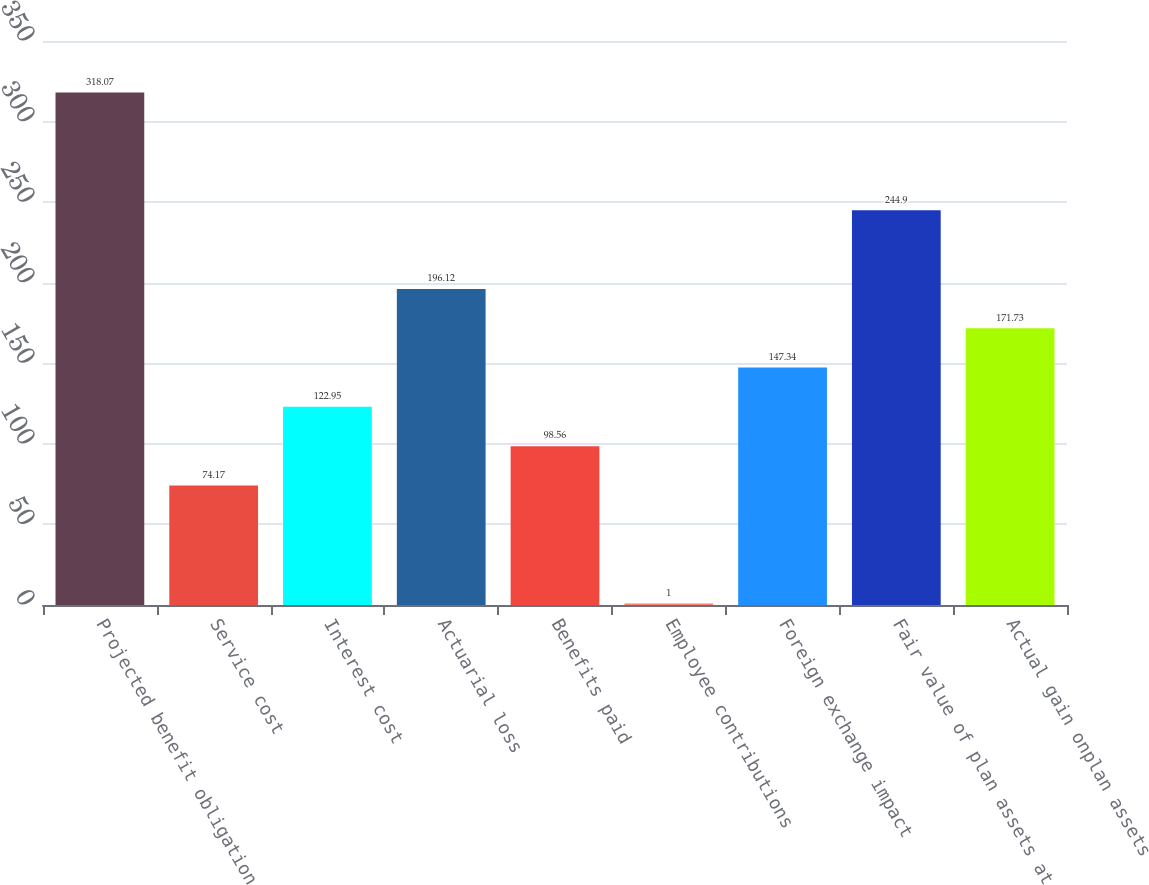Convert chart. <chart><loc_0><loc_0><loc_500><loc_500><bar_chart><fcel>Projected benefit obligation<fcel>Service cost<fcel>Interest cost<fcel>Actuarial loss<fcel>Benefits paid<fcel>Employee contributions<fcel>Foreign exchange impact<fcel>Fair value of plan assets at<fcel>Actual gain onplan assets<nl><fcel>318.07<fcel>74.17<fcel>122.95<fcel>196.12<fcel>98.56<fcel>1<fcel>147.34<fcel>244.9<fcel>171.73<nl></chart> 